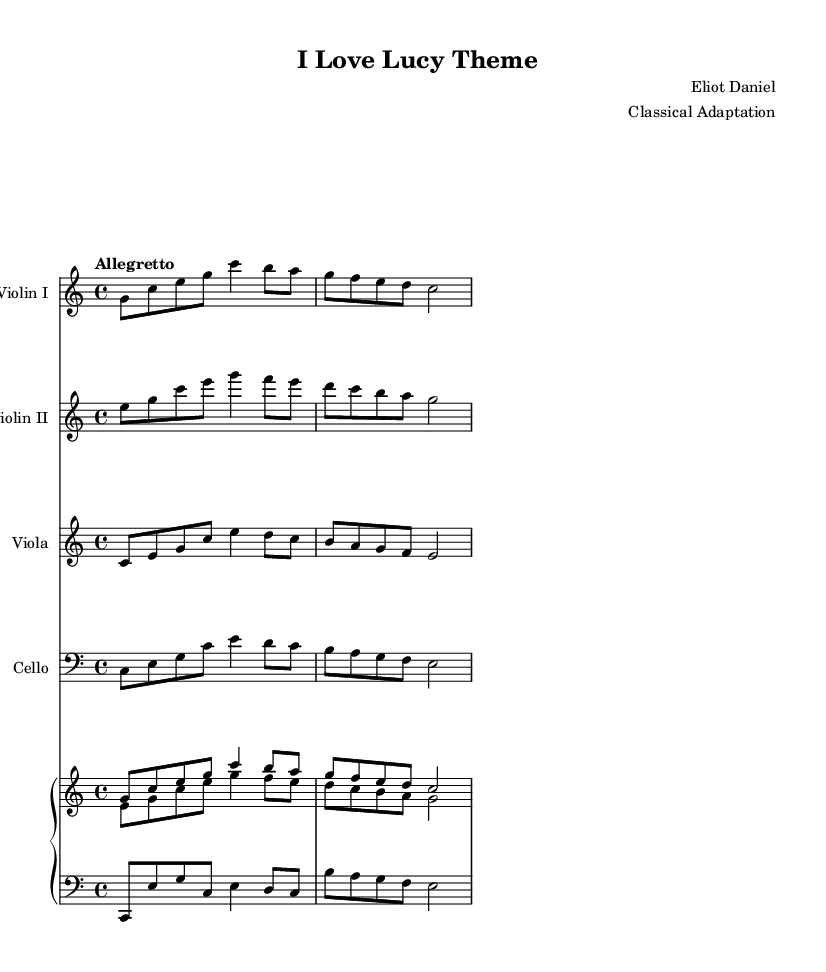What is the key signature of this music? The key signature is indicated at the beginning of the notation, and this piece is in C major, which has no sharps or flats.
Answer: C major What is the time signature of this music? The time signature is located right after the key signature, shown as 4/4. This indicates there are four beats in a measure and the quarter note gets one beat.
Answer: 4/4 What is the tempo marking for this piece? The tempo marking is indicated above the staff, and it reads "Allegretto," which suggests a moderately fast speed typically around 98-109 beats per minute.
Answer: Allegretto How many instruments are included in this arrangement? By counting the different staffs in the score, we see there are five: Violin I, Violin II, Viola, Cello, and Piano.
Answer: Five Which instrument has the highest pitch in this arrangement? The highest pitch is found in the Violin I part, as violins are tuned higher than violas, cellos, and the piano's lower staff.
Answer: Violin I In which section does the recurring melody primarily appear? The recurring melody can primarily be found in the Violin I and Piano (upper staff) parts, both of which have the same melody in their first measures.
Answer: Violin I and Piano 